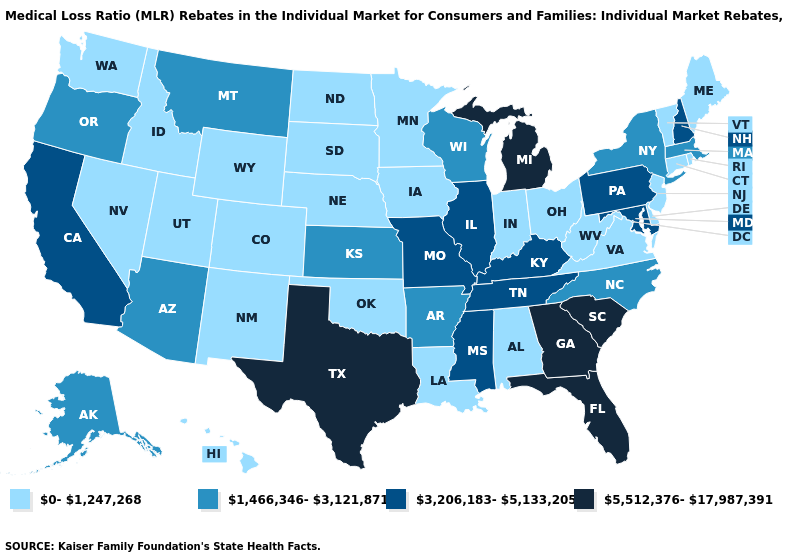Among the states that border Wisconsin , does Illinois have the lowest value?
Be succinct. No. What is the highest value in the USA?
Give a very brief answer. 5,512,376-17,987,391. What is the value of Wisconsin?
Write a very short answer. 1,466,346-3,121,871. What is the value of Arizona?
Short answer required. 1,466,346-3,121,871. Does the first symbol in the legend represent the smallest category?
Give a very brief answer. Yes. Which states have the highest value in the USA?
Give a very brief answer. Florida, Georgia, Michigan, South Carolina, Texas. Does the first symbol in the legend represent the smallest category?
Quick response, please. Yes. Name the states that have a value in the range 1,466,346-3,121,871?
Keep it brief. Alaska, Arizona, Arkansas, Kansas, Massachusetts, Montana, New York, North Carolina, Oregon, Wisconsin. What is the lowest value in the USA?
Keep it brief. 0-1,247,268. Name the states that have a value in the range 0-1,247,268?
Keep it brief. Alabama, Colorado, Connecticut, Delaware, Hawaii, Idaho, Indiana, Iowa, Louisiana, Maine, Minnesota, Nebraska, Nevada, New Jersey, New Mexico, North Dakota, Ohio, Oklahoma, Rhode Island, South Dakota, Utah, Vermont, Virginia, Washington, West Virginia, Wyoming. Name the states that have a value in the range 3,206,183-5,133,205?
Concise answer only. California, Illinois, Kentucky, Maryland, Mississippi, Missouri, New Hampshire, Pennsylvania, Tennessee. Name the states that have a value in the range 1,466,346-3,121,871?
Concise answer only. Alaska, Arizona, Arkansas, Kansas, Massachusetts, Montana, New York, North Carolina, Oregon, Wisconsin. What is the value of Wisconsin?
Give a very brief answer. 1,466,346-3,121,871. Which states hav the highest value in the MidWest?
Quick response, please. Michigan. Which states hav the highest value in the South?
Keep it brief. Florida, Georgia, South Carolina, Texas. 